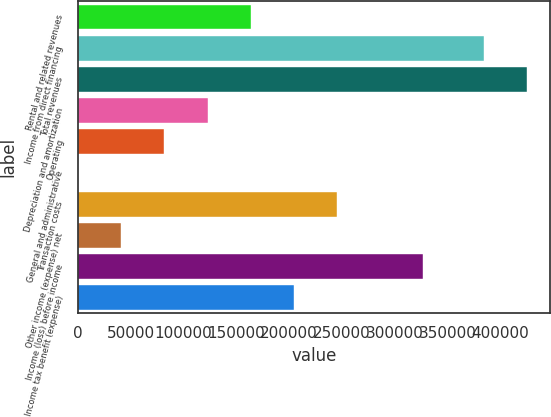<chart> <loc_0><loc_0><loc_500><loc_500><bar_chart><fcel>Rental and related revenues<fcel>Income from direct financing<fcel>Total revenues<fcel>Depreciation and amortization<fcel>Operating<fcel>General and administrative<fcel>Transaction costs<fcel>Other income (expense) net<fcel>Income (loss) before income<fcel>Income tax benefit (expense)<nl><fcel>163623<fcel>384752<fcel>425641<fcel>122734<fcel>81844.8<fcel>67<fcel>245400<fcel>40955.9<fcel>327178<fcel>204512<nl></chart> 